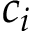<formula> <loc_0><loc_0><loc_500><loc_500>c _ { i }</formula> 